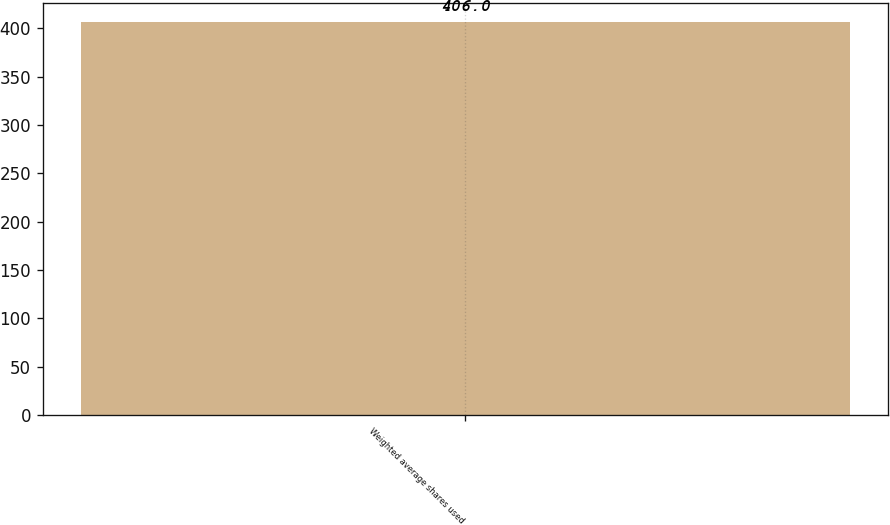Convert chart. <chart><loc_0><loc_0><loc_500><loc_500><bar_chart><fcel>Weighted average shares used<nl><fcel>406<nl></chart> 